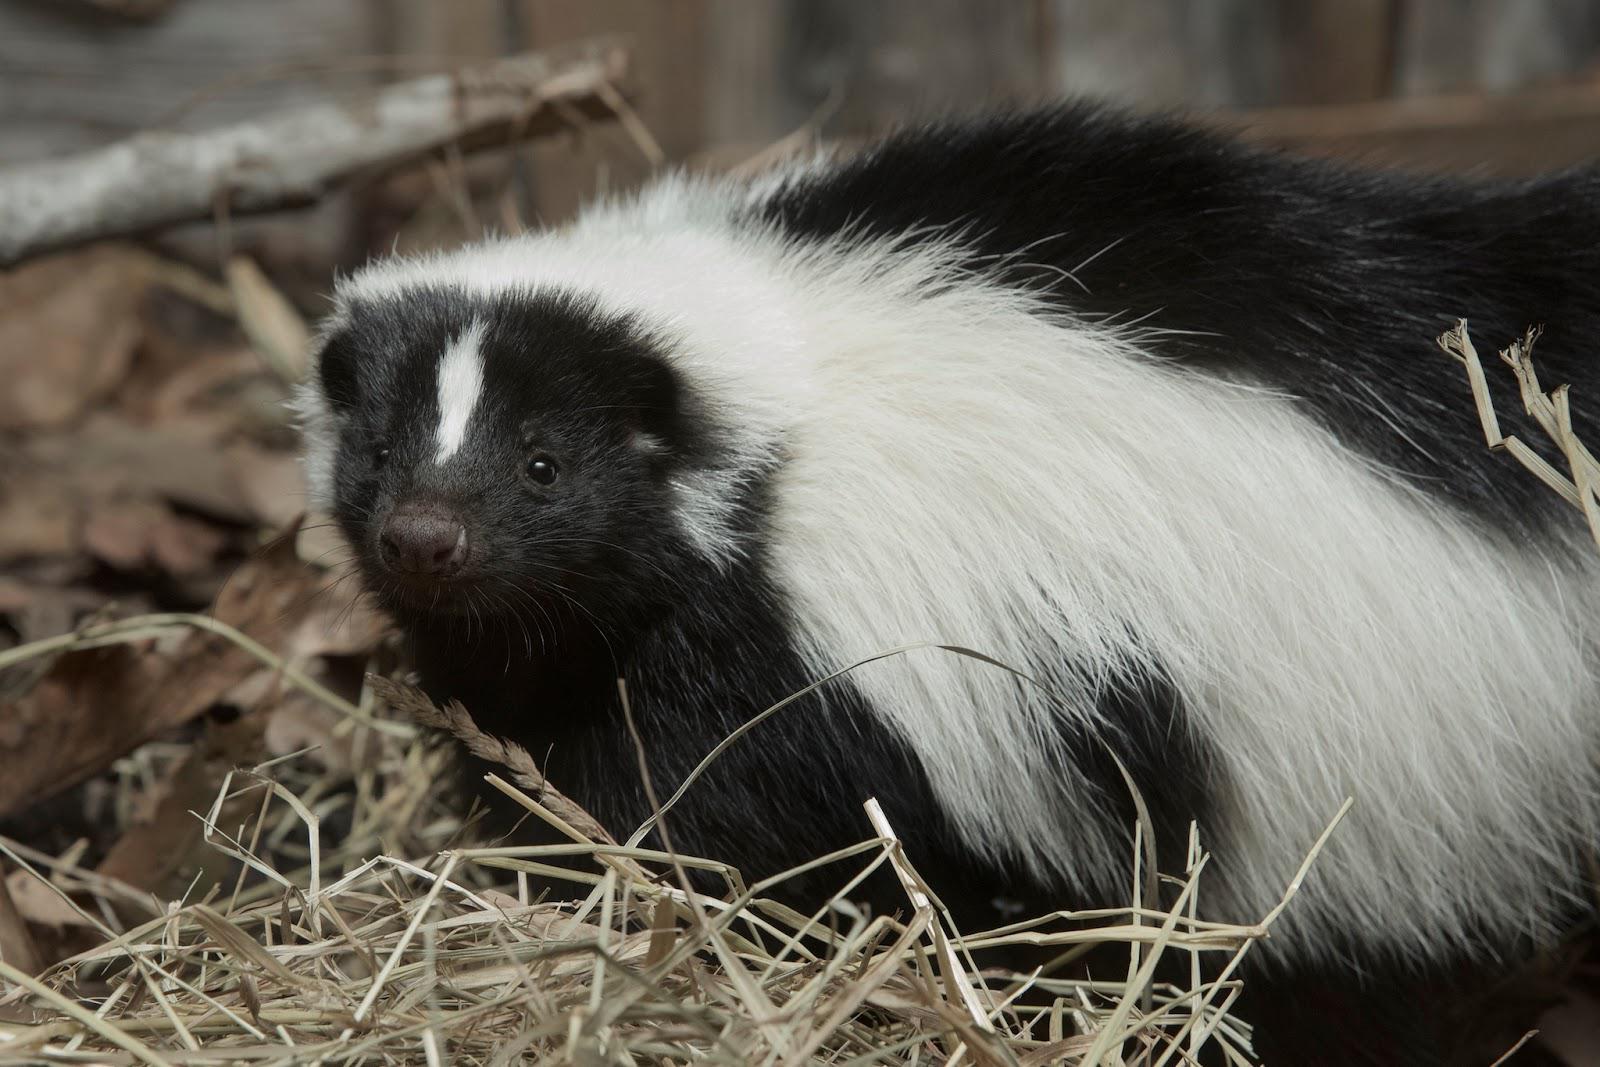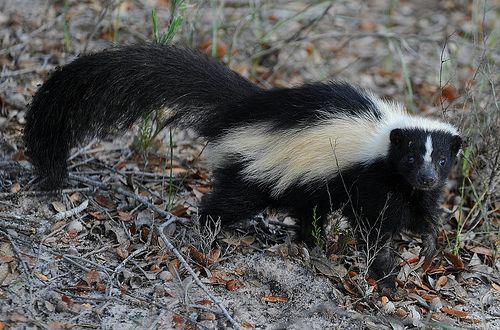The first image is the image on the left, the second image is the image on the right. Analyze the images presented: Is the assertion "There is a skunk coming out from under a fallen tree log" valid? Answer yes or no. No. 